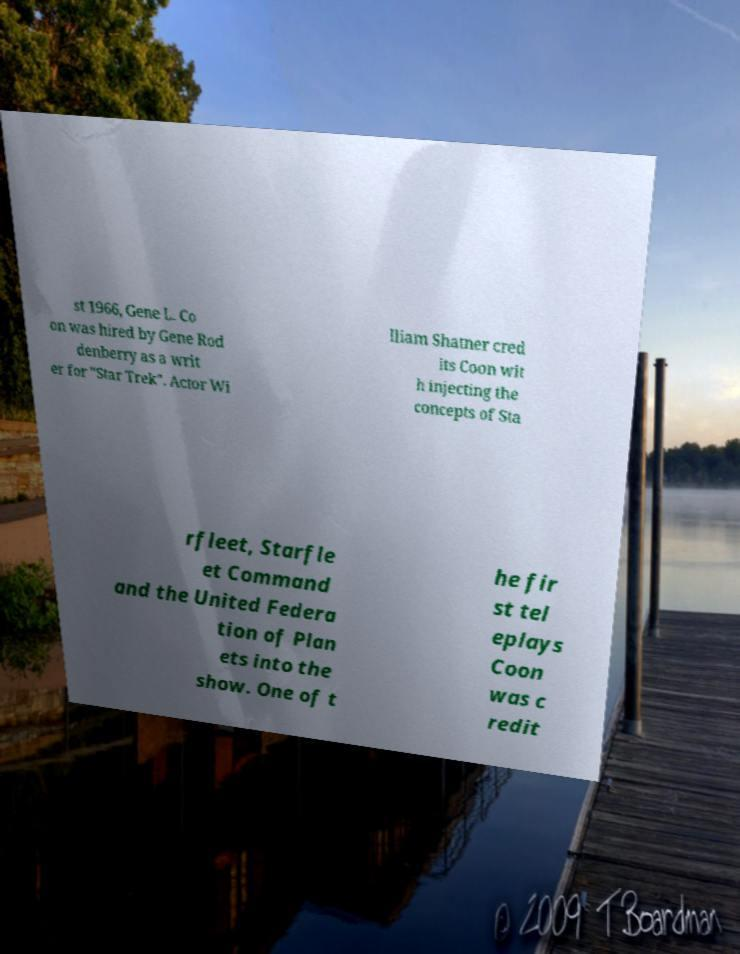Could you extract and type out the text from this image? st 1966, Gene L. Co on was hired by Gene Rod denberry as a writ er for "Star Trek". Actor Wi lliam Shatner cred its Coon wit h injecting the concepts of Sta rfleet, Starfle et Command and the United Federa tion of Plan ets into the show. One of t he fir st tel eplays Coon was c redit 